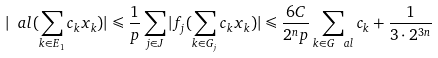<formula> <loc_0><loc_0><loc_500><loc_500>| \ a l ( \sum _ { k \in E _ { 1 } } c _ { k } x _ { k } ) | \leqslant \frac { 1 } { p } \sum _ { j \in J } | f _ { j } ( \sum _ { k \in G _ { j } } c _ { k } x _ { k } ) | \leqslant \frac { 6 C } { 2 ^ { n } p } \sum _ { k \in G _ { \ } a l } c _ { k } + \frac { 1 } { 3 \cdot 2 ^ { 3 n } }</formula> 